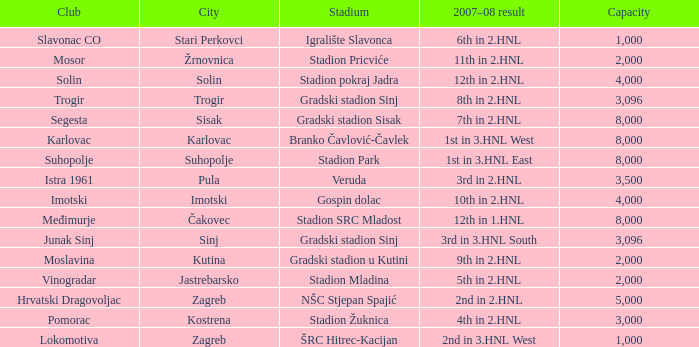What stadium has kutina as the city? Gradski stadion u Kutini. 